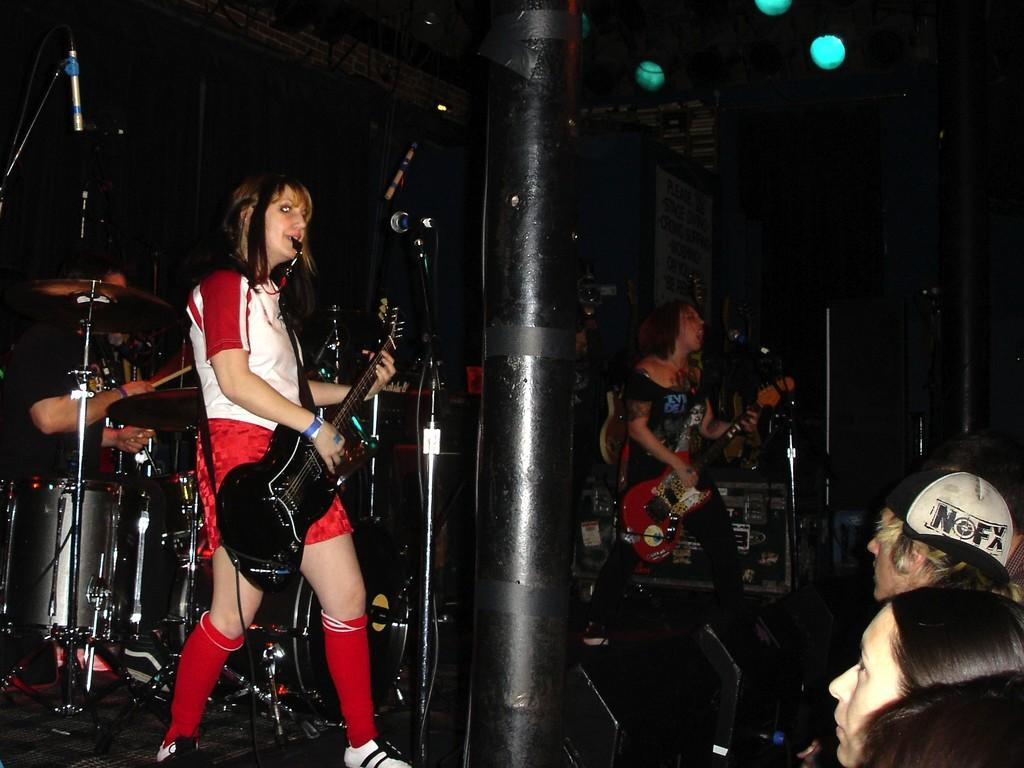What is the woman in the image doing? The woman is playing a guitar in the image. What else can be seen in the image besides the woman? There are musical instruments and a crowd in the image. What is the central object in the image? There is a pole in the center of the image. How many rabbits are hopping around the pole in the image? There are no rabbits present in the image; it features a woman playing a guitar, musical instruments, and a crowd. 